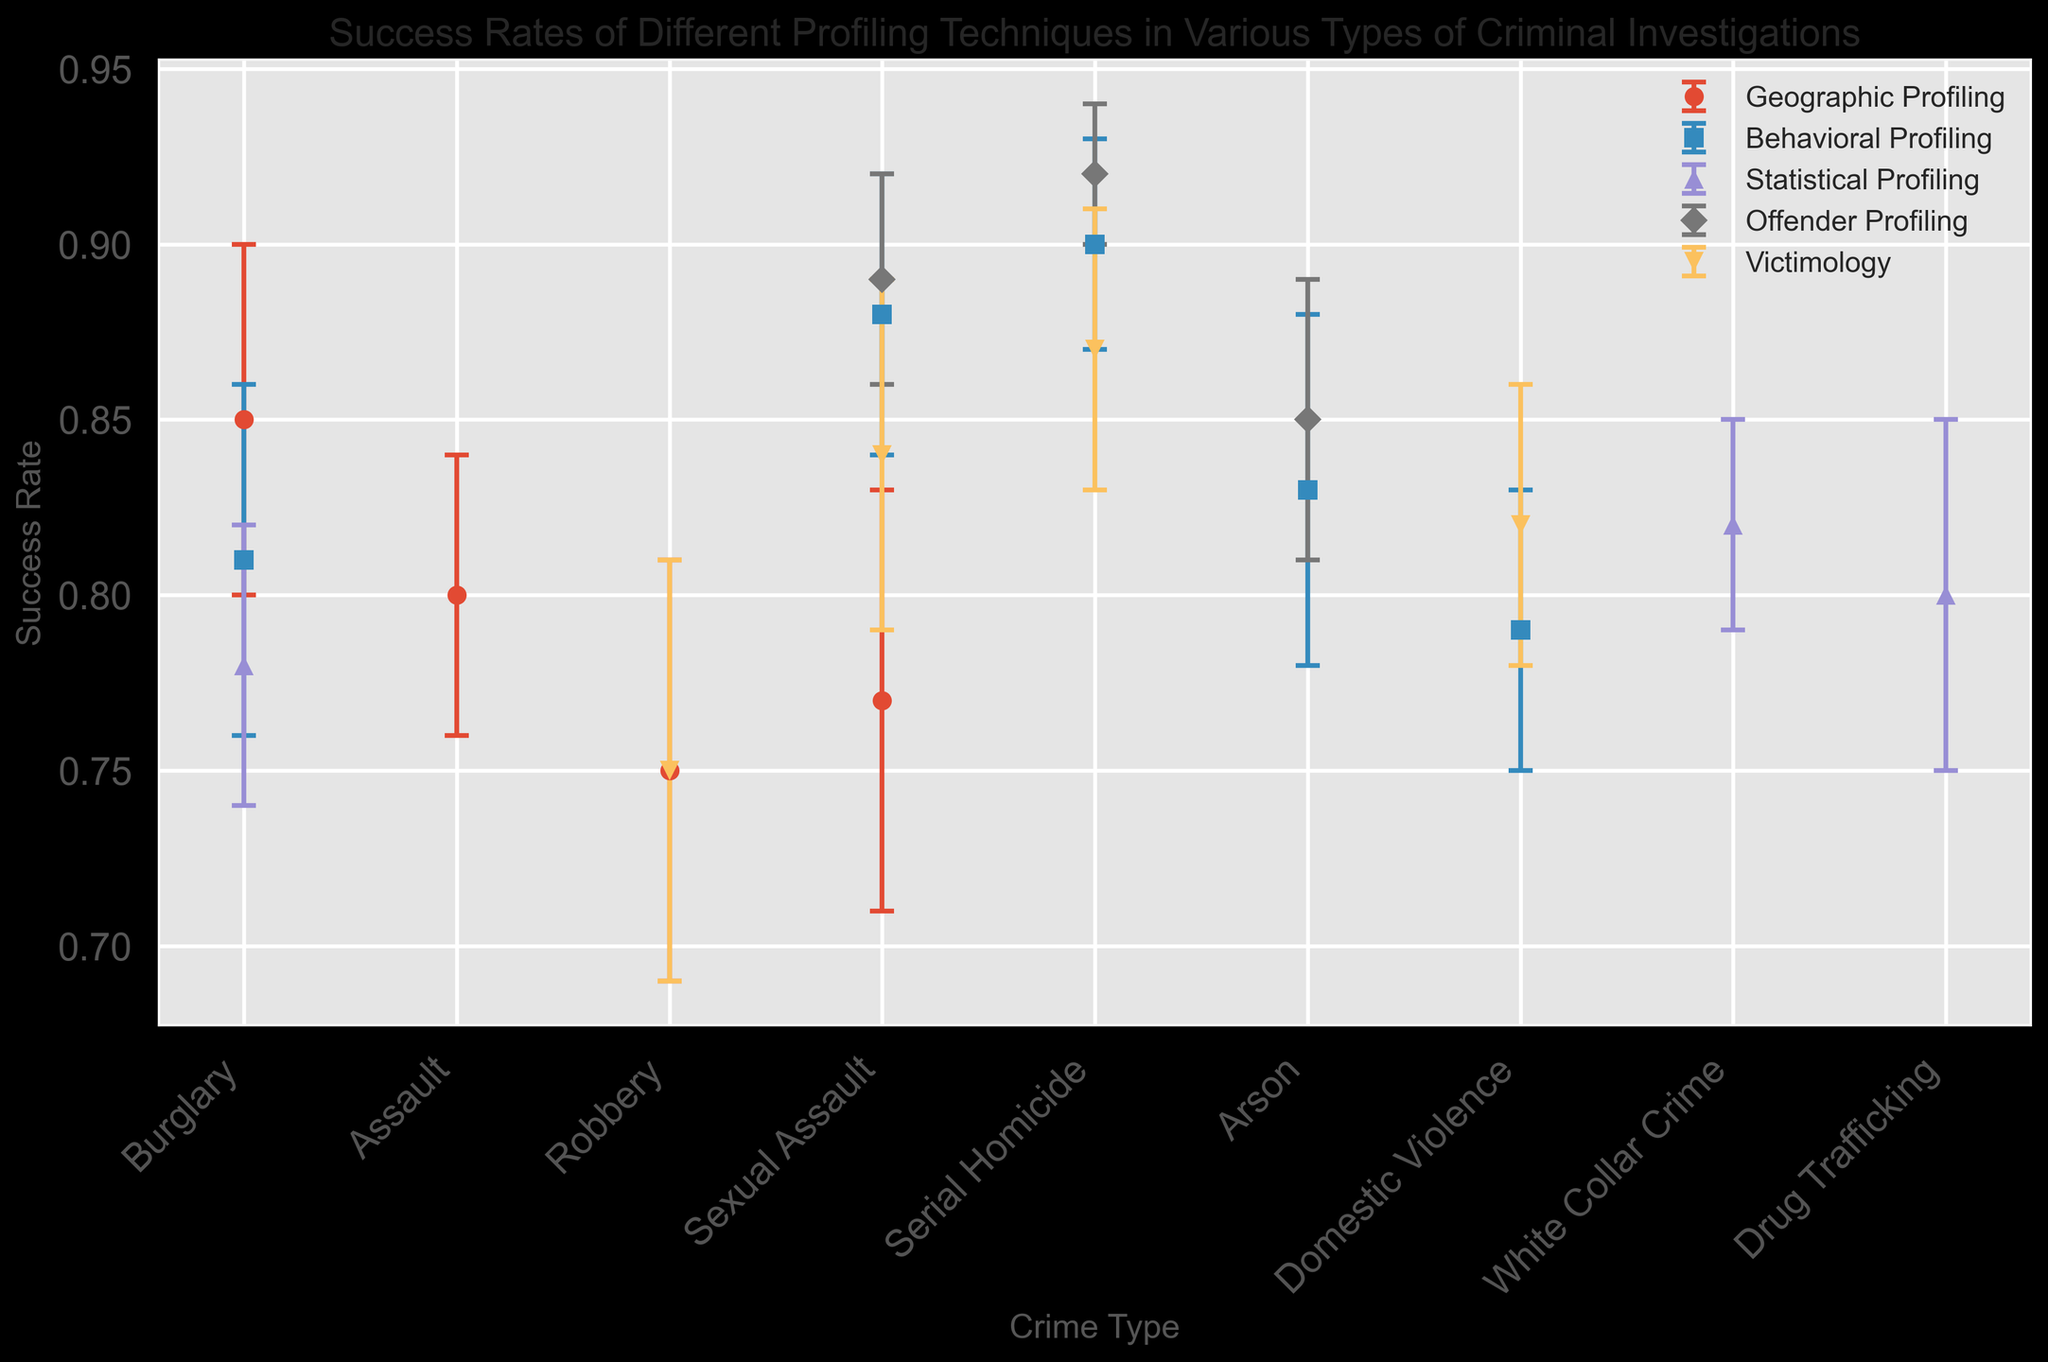What profiling technique has the highest success rate for Sexual Assault cases? To find the profiling technique with the highest success rate for Sexual Assault cases, look at all the data points corresponding to this crime type and identify the highest value. Based on the data, Offender Profiling has a success rate of 0.89 for Sexual Assault cases.
Answer: Offender Profiling Which profiling technique has the lowest turnaround time for Burglary investigations? To determine the profiling technique with the lowest turnaround time, check the data points for Burglary and compare the turnaround times for each technique. Geographic Profiling has the lowest turnaround time at 12 days for Burglary investigations.
Answer: Geographic Profiling Among all profiling techniques, which has the greatest variability in success rate for Serial Homicide cases? To determine variability, look at the standard deviations for each profiling technique associated with Serial Homicide cases. Behavioral Profiling and Offender Profiling both are associated, but Behavioral Profiling has a standard deviation of 0.03 compared to Offender Profiling’s lower 0.02, making it the most variable.
Answer: Behavioral Profiling Which profiling technique has the smallest error margin for success rates in Arson investigations? Error margin is indicated by the standard deviation of the success rates. Check the standard deviations for Arson across profiling techniques. Offender Profiling has the smallest standard deviation of 0.04.
Answer: Offender Profiling Compare the success rate of Geographic Profiling and Behavioral Profiling in Burglary investigation. Which one is higher and by how much? Compare the success rates for both techniques in Burglary. Geographic Profiling has a success rate of 0.85 while Behavioral Profiling has a success rate of 0.81. The difference is 0.85 - 0.81 = 0.04.
Answer: Geographic Profiling by 0.04 Calculate the average turnaround time for Victimology across all crime types. Identify all turnaround times for Victimology across the crime types: 18 for Serial Homicide, 20 for Sexual Assault, 16 for Domestic Violence, and 15 for Robbery. Sum them: 18 + 20 + 16 + 15 = 69. Then divide by the number of observations (4): 69 / 4 = 17.25.
Answer: 17.25 days Which profiling technique demonstrates the highest success rate variability across all crime types? To discover the highest variability, compare the standard deviations for success rates among the techniques across all crime types. Behavioral Profiling has standard deviations of 0.03, 0.04, 0.05, and 0.04, indicating high variability.
Answer: Behavioral Profiling What is the difference in turnaround time between the fastest and the slowest techniques for Drug Trafficking investigations? Identify the turnaround times for the techniques involved in Drug Trafficking cases. Statistical Profiling is the only technique listed with a turnaround time of 19. Since no other profiling techniques are listed for comparison, the difference is 0.
Answer: 0 days Is there any crime type where all profiling techniques have an equal success rate? To determine if there's equality, assess each crime type's success rates and look for a common value. Based on the data provided, no single crime type shows equal success rates across all profiling techniques.
Answer: No What is the median success rate of Offender Profiling across all crime types? Find the success rates for Offender Profiling: 0.92 (Serial Homicide), 0.89 (Sexual Assault), and 0.85 (Arson). There are three values: 0.85, 0.89, and 0.92. The median is the middle value, 0.89.
Answer: 0.89 